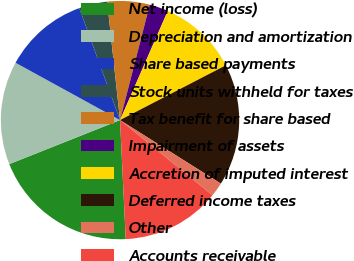<chart> <loc_0><loc_0><loc_500><loc_500><pie_chart><fcel>Net income (loss)<fcel>Depreciation and amortization<fcel>Share based payments<fcel>Stock units withheld for taxes<fcel>Tax benefit for share based<fcel>Impairment of assets<fcel>Accretion of imputed interest<fcel>Deferred income taxes<fcel>Other<fcel>Accounts receivable<nl><fcel>19.74%<fcel>14.01%<fcel>11.46%<fcel>3.83%<fcel>5.74%<fcel>2.55%<fcel>10.83%<fcel>16.55%<fcel>1.92%<fcel>13.37%<nl></chart> 